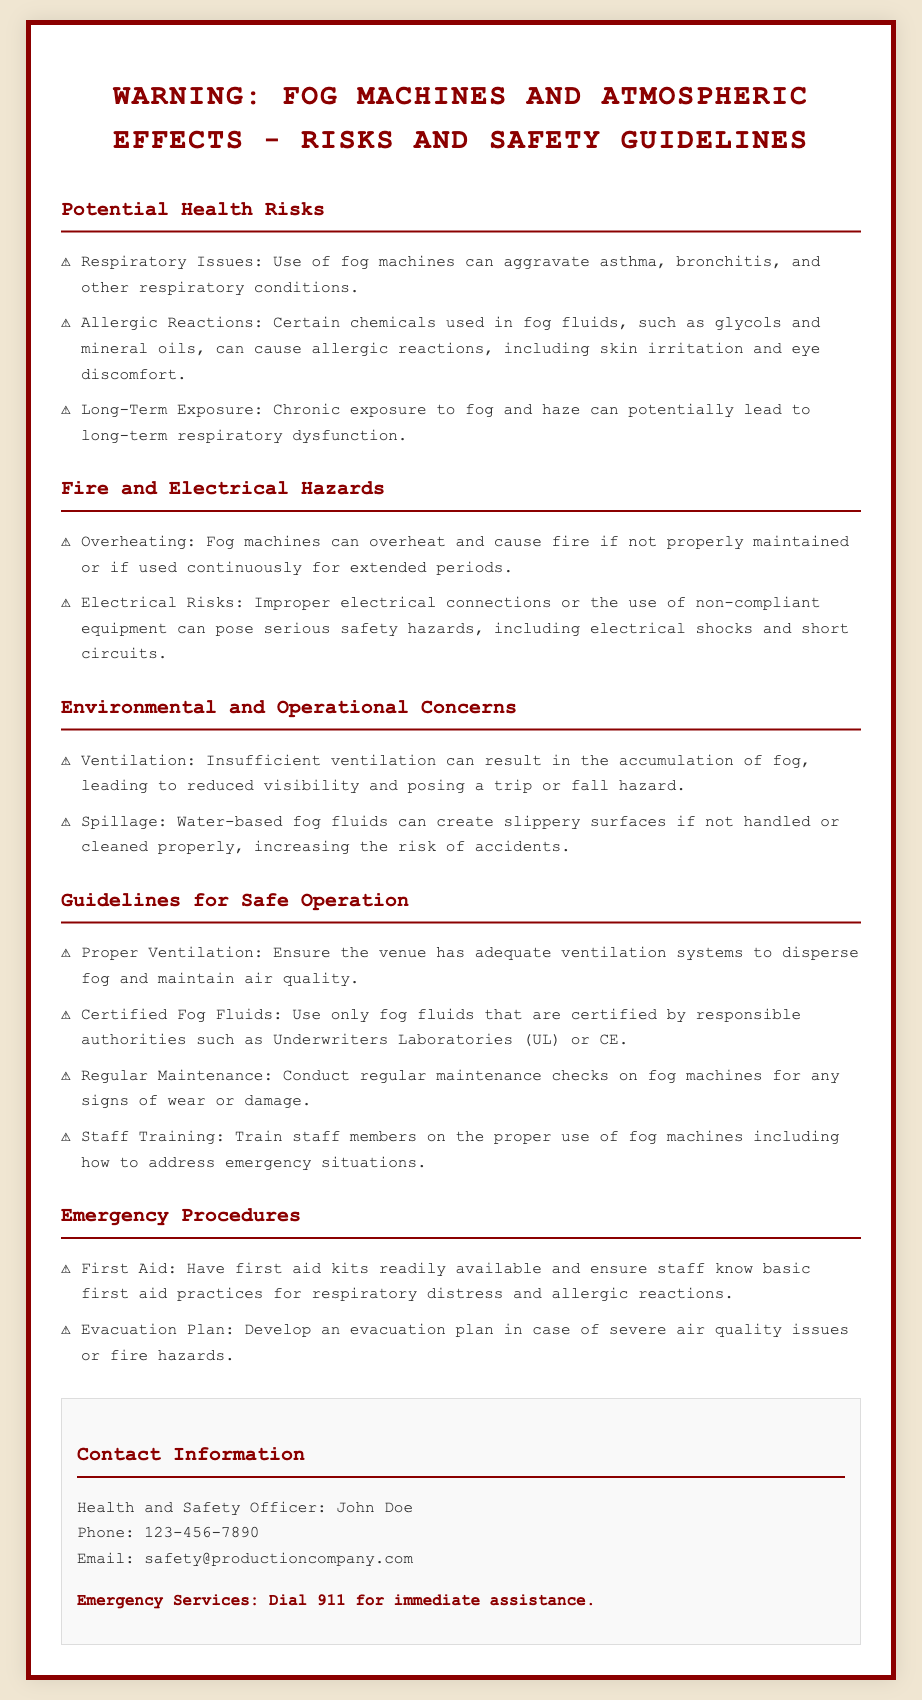What are the potential health risks? The potential health risks listed in the document include respiratory issues, allergic reactions, and long-term exposure risks.
Answer: Respiratory issues, allergic reactions, long-term exposure What should be ensured for safe operation? The guidelines for safe operation require proper ventilation, use of certified fog fluids, regular maintenance, and staff training.
Answer: Proper ventilation, certified fog fluids, regular maintenance, staff training Who is the Health and Safety Officer? The document mentions the name of the Health and Safety Officer who is responsible for safety protocols.
Answer: John Doe What should be done in case of severe air quality issues? The document advises to have an evacuation plan for emergency situations related to air quality or fire hazards.
Answer: Evacuation plan What are the fire hazards mentioned? The document describes two specific fire hazards related to fog machines: overheating and electrical risks.
Answer: Overheating, electrical risks What chemical types can cause allergic reactions? The document specifies certain chemicals used in fog fluids that may lead to allergic reactions.
Answer: Glycols, mineral oils How can insufficient ventilation affect the environment? Insufficient ventilation can lead to accidents due to reduced visibility and increased risks of slips or falls.
Answer: Reduced visibility, trip or fall hazard 